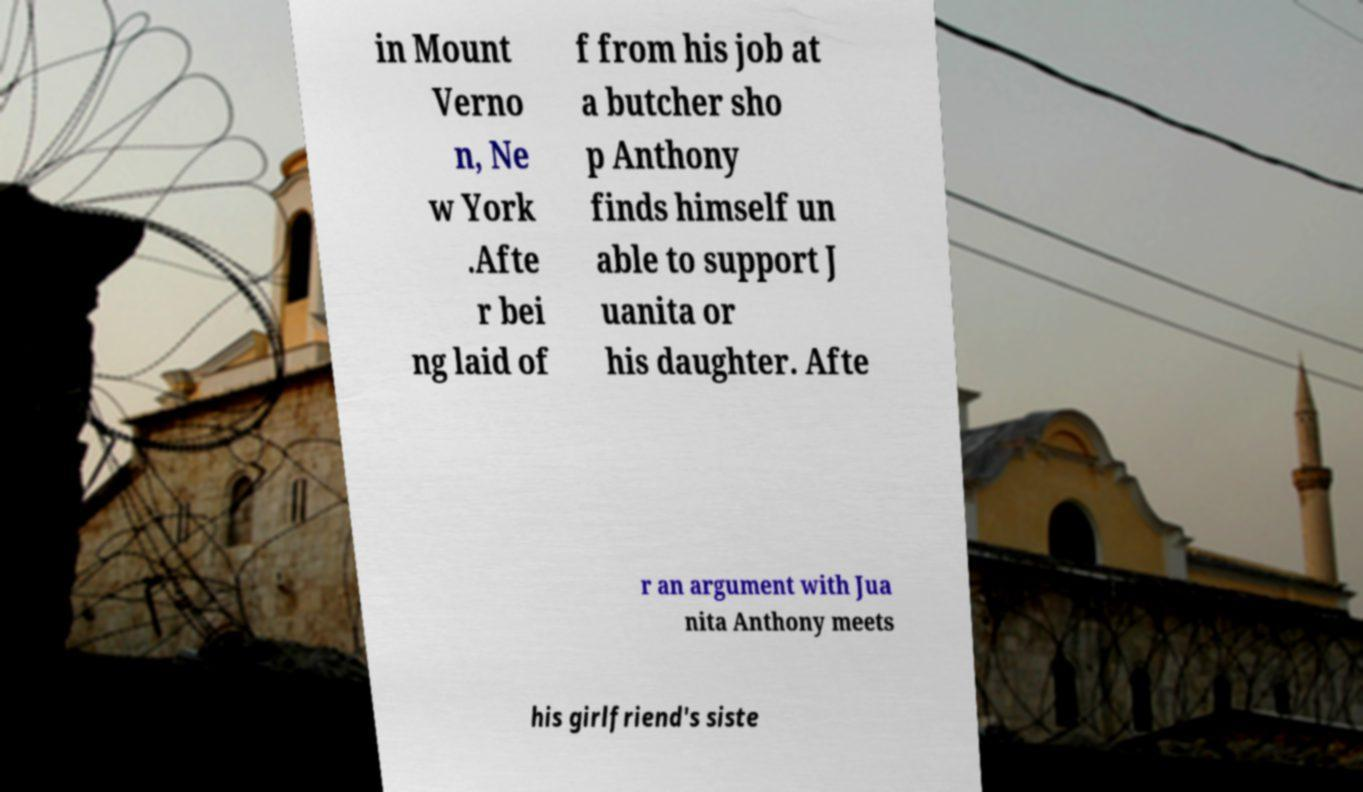Could you assist in decoding the text presented in this image and type it out clearly? in Mount Verno n, Ne w York .Afte r bei ng laid of f from his job at a butcher sho p Anthony finds himself un able to support J uanita or his daughter. Afte r an argument with Jua nita Anthony meets his girlfriend's siste 